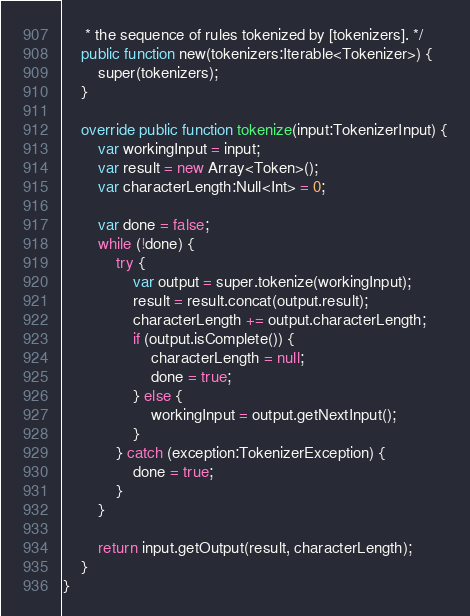Convert code to text. <code><loc_0><loc_0><loc_500><loc_500><_Haxe_>     * the sequence of rules tokenized by [tokenizers]. */
    public function new(tokenizers:Iterable<Tokenizer>) {
        super(tokenizers);
    }

    override public function tokenize(input:TokenizerInput) {
        var workingInput = input;
        var result = new Array<Token>();
        var characterLength:Null<Int> = 0;

        var done = false;
        while (!done) {
            try {
                var output = super.tokenize(workingInput);
                result = result.concat(output.result);
                characterLength += output.characterLength;
                if (output.isComplete()) {
                    characterLength = null;
                    done = true;
                } else {
                    workingInput = output.getNextInput();
                }
            } catch (exception:TokenizerException) {
                done = true;
            }
        }

        return input.getOutput(result, characterLength);
    }
}
</code> 